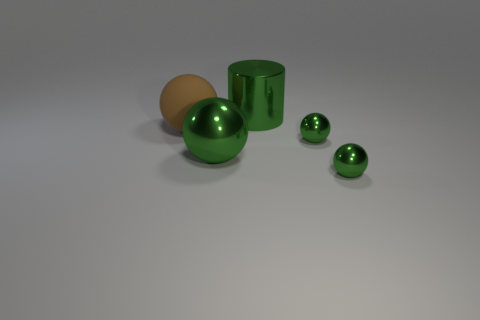Are there any other things that have the same material as the large brown sphere?
Your answer should be very brief. No. There is a thing that is behind the big brown thing; does it have the same color as the big sphere that is on the right side of the brown rubber ball?
Your response must be concise. Yes. Do the tiny thing that is in front of the large shiny ball and the big cylinder have the same color?
Offer a terse response. Yes. There is a small green thing that is in front of the tiny green metallic ball that is behind the big metal thing in front of the rubber ball; what is its material?
Keep it short and to the point. Metal. Is the number of large things that are in front of the rubber sphere greater than the number of big green metallic things in front of the green cylinder?
Provide a short and direct response. No. There is another big object that is the same shape as the big brown object; what color is it?
Give a very brief answer. Green. What number of small objects have the same color as the metal cylinder?
Your response must be concise. 2. Are there more green metallic objects on the left side of the green cylinder than purple balls?
Your answer should be very brief. Yes. There is a small sphere that is to the left of the metallic object in front of the large green ball; what color is it?
Give a very brief answer. Green. How many things are either metallic balls that are right of the big green metal cylinder or objects that are to the left of the metal cylinder?
Offer a very short reply. 4. 